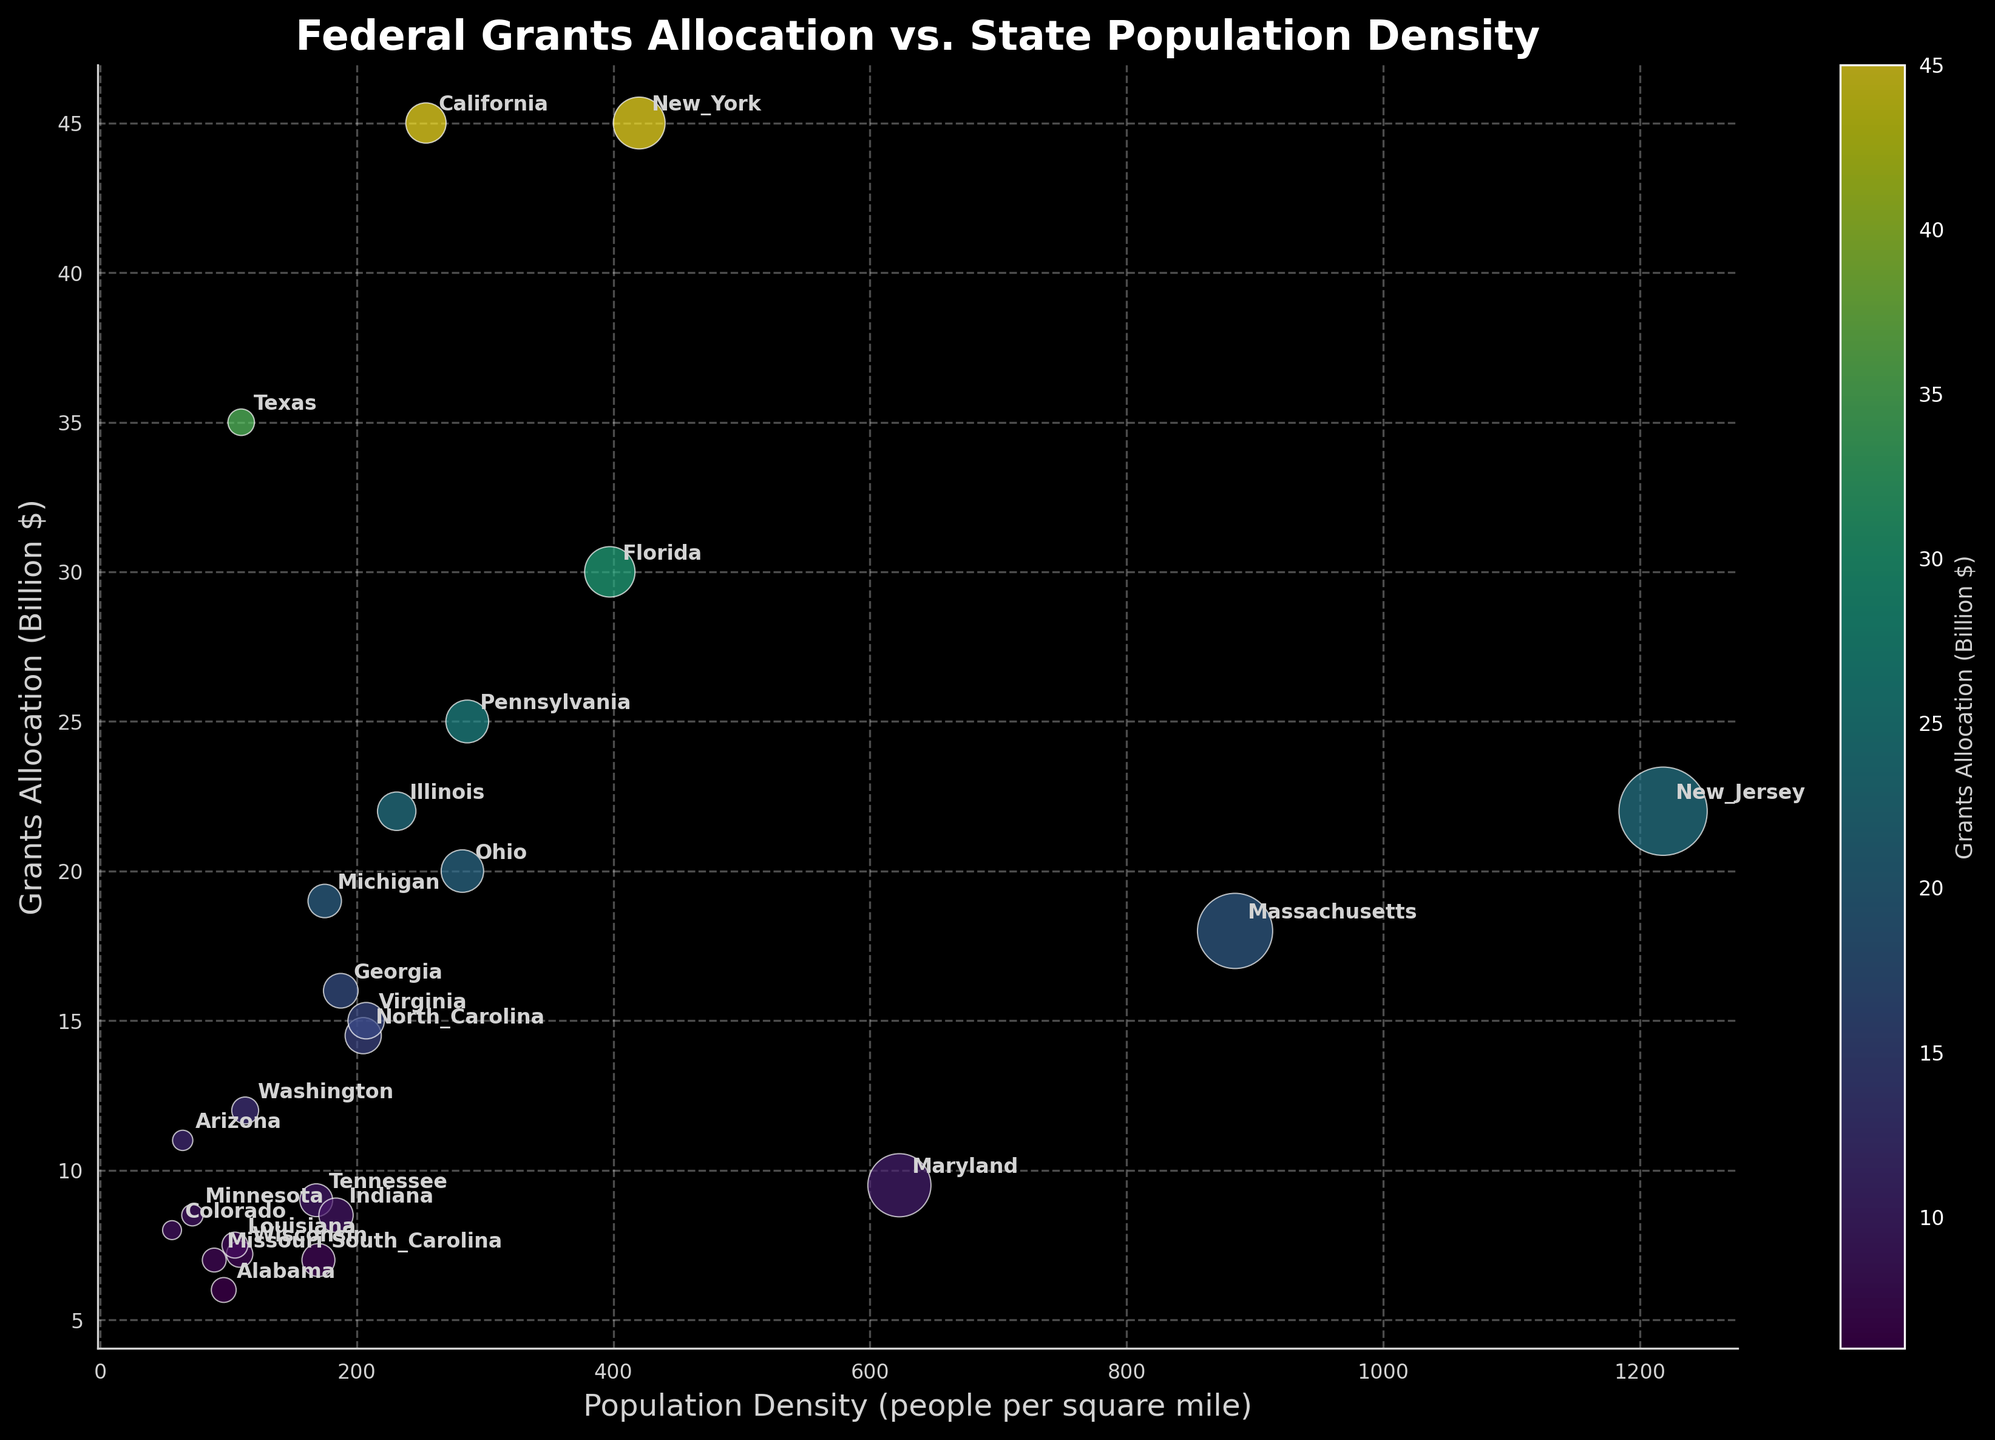What is the title of the scatter plot? The title of the graph is displayed at the top. According to the information given, the title should read: "Federal Grants Allocation vs. State Population Density".
Answer: Federal Grants Allocation vs. State Population Density What does the x-axis represent? The x-axis label indicates what it represents. In this case, the x-axis label is 'Population Density (people per square mile)'.
Answer: Population Density (people per square mile) What does the y-axis represent? The y-axis label indicates what it represents. In this case, the y-axis label is 'Grants Allocation (Billion $)'.
Answer: Grants Allocation (Billion $) Which state has the highest population density? By looking at the scatter plot, we identify the state point that is furthest along the x-axis (Population Density). According to the dataset, New Jersey has the highest population density at 1218.1.
Answer: New Jersey Which state received the highest amount of federal grants? By observing the scatter plot, the highest point on the y-axis (Grants Allocation) would represent the state with the highest grants. According to the dataset, both California and New York received the highest grants of $45 billion.
Answer: California and New York What is the approximate grants allocation value for Texas? Locate the Texas annotation on the plot and check its position on the y-axis to determine its grants allocation. The dataset shows Texas received $35 billion in grants.
Answer: $35 billion How many states have a grants allocation of $20 billion? Look for points on the scatter plot at the grants allocation level (y-axis) of $20 billion. According to the dataset, Ohio and New Jersey each have a grants allocation of $20 billion.
Answer: Two Which state has a higher population density, Arizona or Colorado? Locate the points for Arizona and Colorado on the scatter plot, then check their x-axis positions. According to the dataset, Arizona has a population density of 64.3, whereas Colorado has a lower density of 56.0.
Answer: Arizona What is the average grants allocation for the states of California, Florida, and Texas? Sum the grants allocation values for California ($45 billion), Florida ($30 billion), and Texas ($35 billion), then divide by 3. (45 + 30 + 35) / 3 = $36.67 billion
Answer: $36.67 billion 